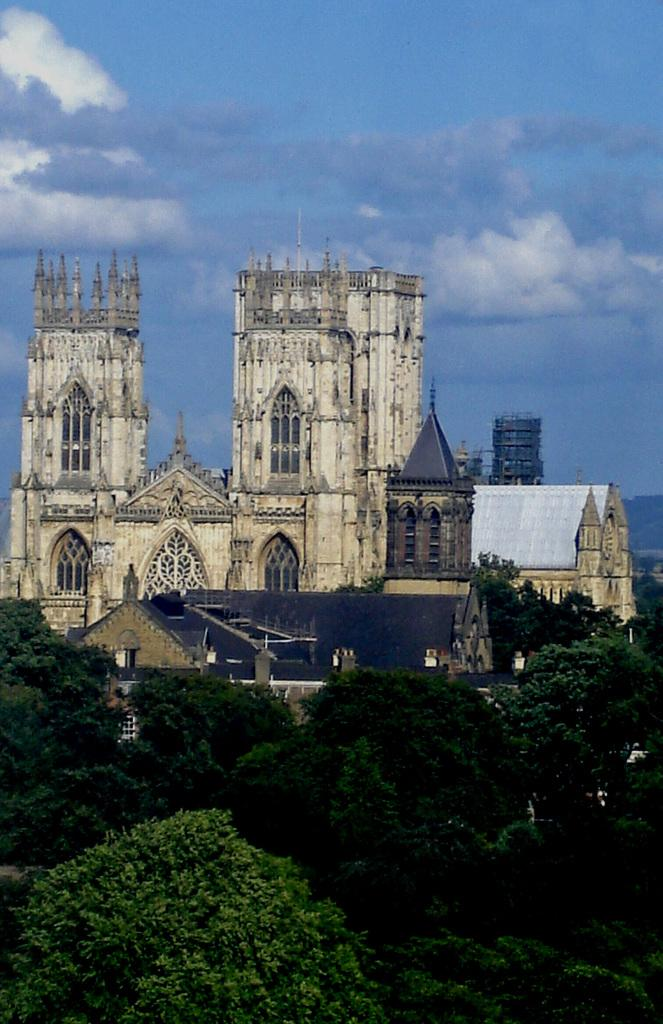What structures can be seen in the image? There are buildings in the image. What type of vegetation is in front of the buildings? There are trees in front of the buildings. What is visible at the top of the image? The sky is visible at the top of the image. How many bags can be seen hanging from the trees in the image? There are no bags present in the image; it features buildings, trees, and the sky. What type of art is displayed on the buildings in the image? There is no art displayed on the buildings in the image; only the buildings, trees, and sky are present. 